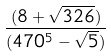Convert formula to latex. <formula><loc_0><loc_0><loc_500><loc_500>\frac { ( 8 + \sqrt { 3 2 6 } ) } { ( 4 7 0 ^ { 5 } - \sqrt { 5 } ) }</formula> 